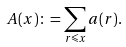<formula> <loc_0><loc_0><loc_500><loc_500>A ( x ) \colon = \sum _ { r \leqslant x } a ( r ) .</formula> 